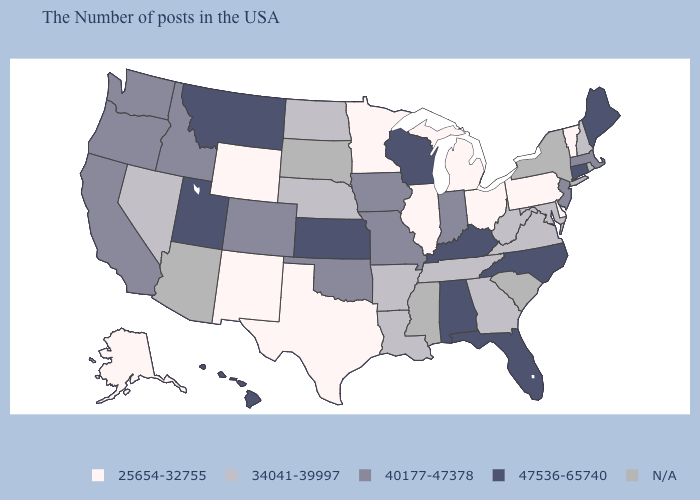Does Indiana have the lowest value in the USA?
Be succinct. No. What is the lowest value in the USA?
Be succinct. 25654-32755. Does the map have missing data?
Be succinct. Yes. What is the value of Kentucky?
Quick response, please. 47536-65740. How many symbols are there in the legend?
Be succinct. 5. What is the highest value in the USA?
Be succinct. 47536-65740. Name the states that have a value in the range N/A?
Answer briefly. Rhode Island, New York, South Carolina, Mississippi, South Dakota, Arizona. What is the lowest value in states that border New Mexico?
Keep it brief. 25654-32755. Which states have the highest value in the USA?
Give a very brief answer. Maine, Connecticut, North Carolina, Florida, Kentucky, Alabama, Wisconsin, Kansas, Utah, Montana, Hawaii. Does Missouri have the highest value in the MidWest?
Keep it brief. No. Name the states that have a value in the range 40177-47378?
Concise answer only. Massachusetts, New Jersey, Indiana, Missouri, Iowa, Oklahoma, Colorado, Idaho, California, Washington, Oregon. What is the value of Louisiana?
Be succinct. 34041-39997. What is the highest value in the South ?
Short answer required. 47536-65740. 